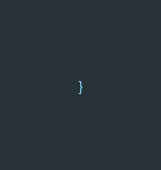Convert code to text. <code><loc_0><loc_0><loc_500><loc_500><_TypeScript_>}
</code> 